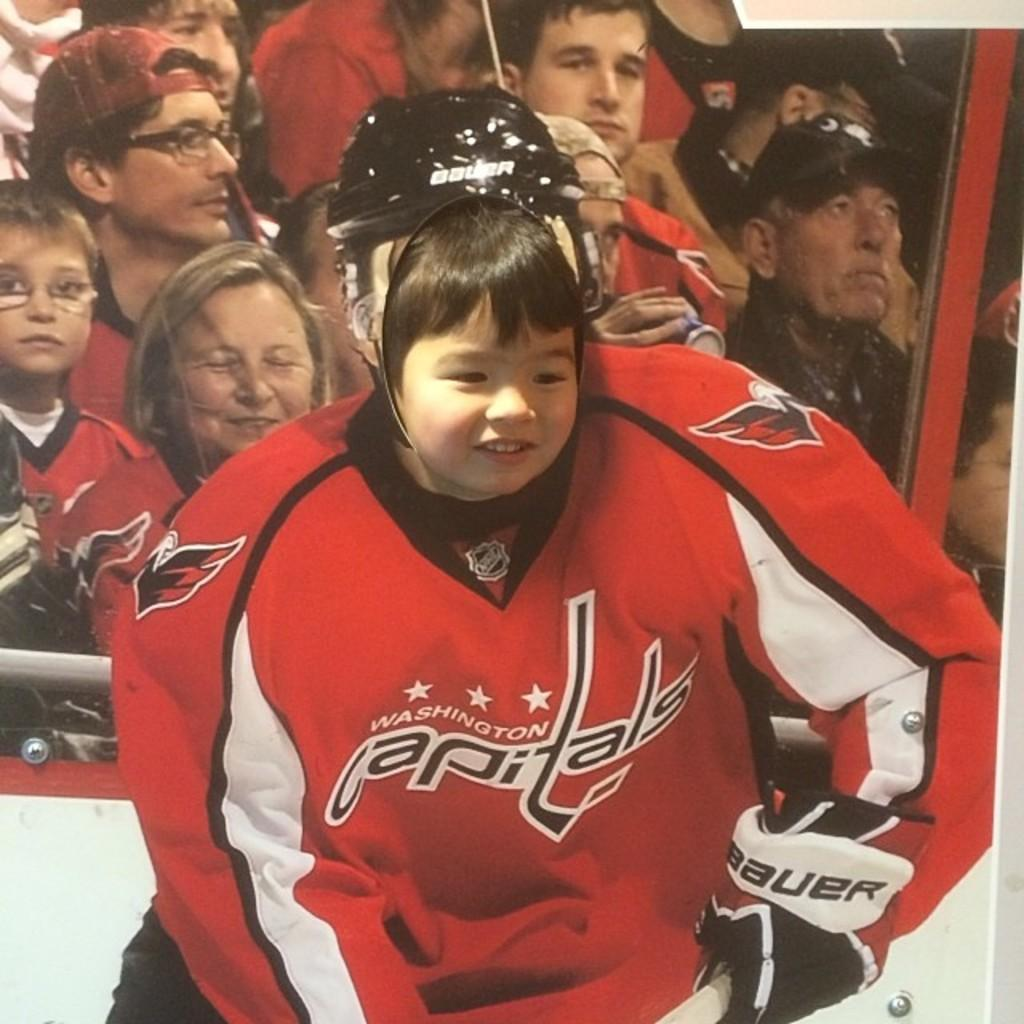<image>
Offer a succinct explanation of the picture presented. A little girl putting her face through a cutout of a capitals hockey player. 